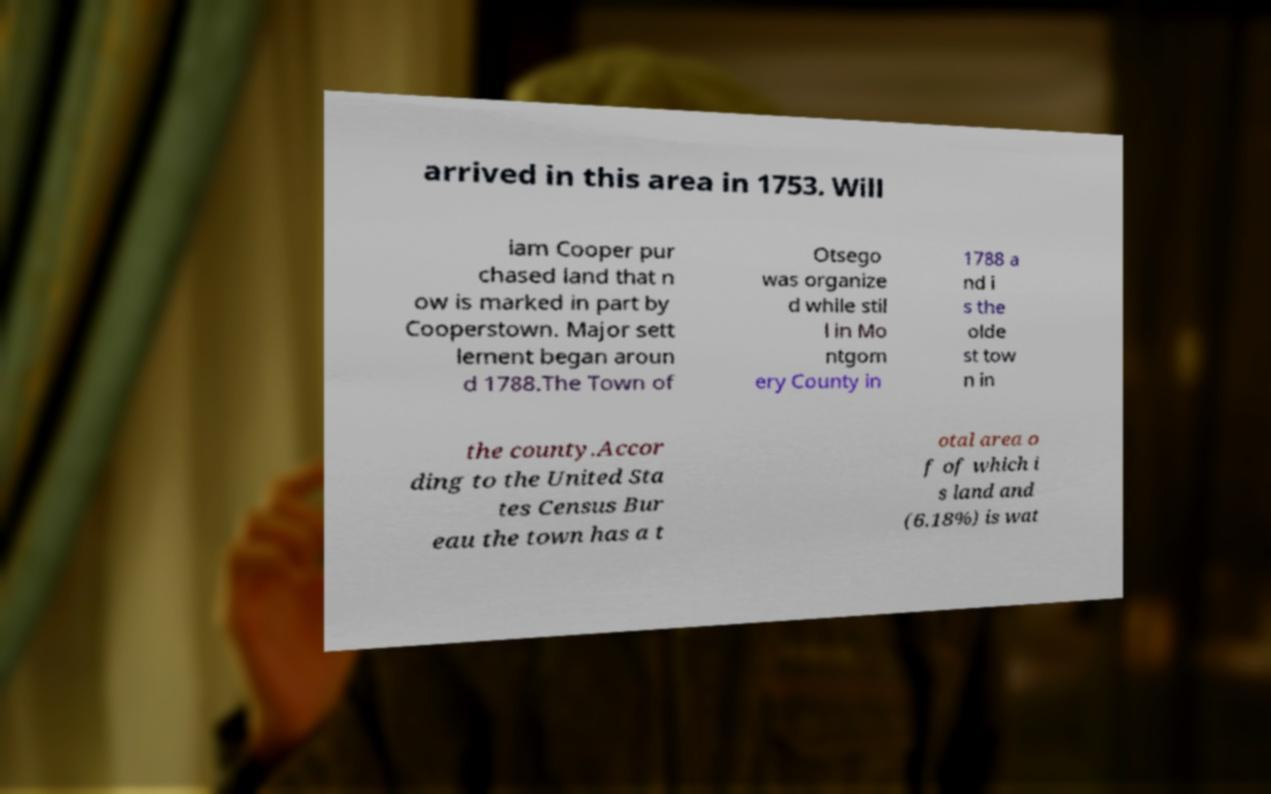Could you extract and type out the text from this image? arrived in this area in 1753. Will iam Cooper pur chased land that n ow is marked in part by Cooperstown. Major sett lement began aroun d 1788.The Town of Otsego was organize d while stil l in Mo ntgom ery County in 1788 a nd i s the olde st tow n in the county.Accor ding to the United Sta tes Census Bur eau the town has a t otal area o f of which i s land and (6.18%) is wat 